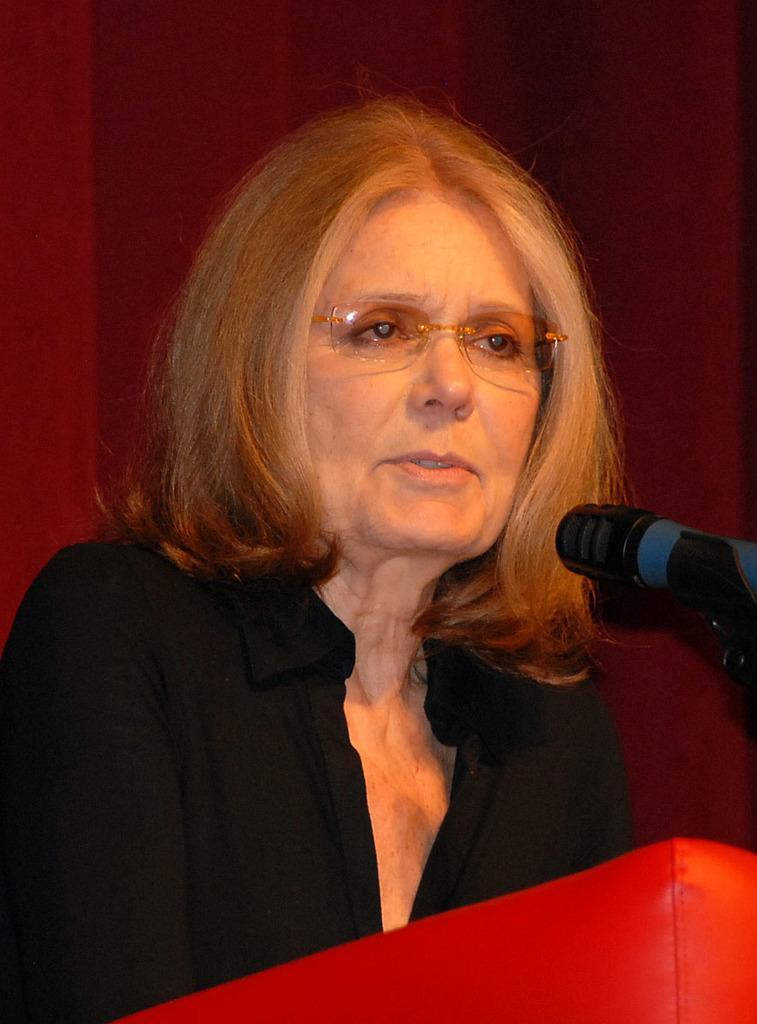Please provide a concise description of this image. In this picture there is a woman behind the podium and she is talking and there are microphones on the podium. At the back it looks like a curtain. 